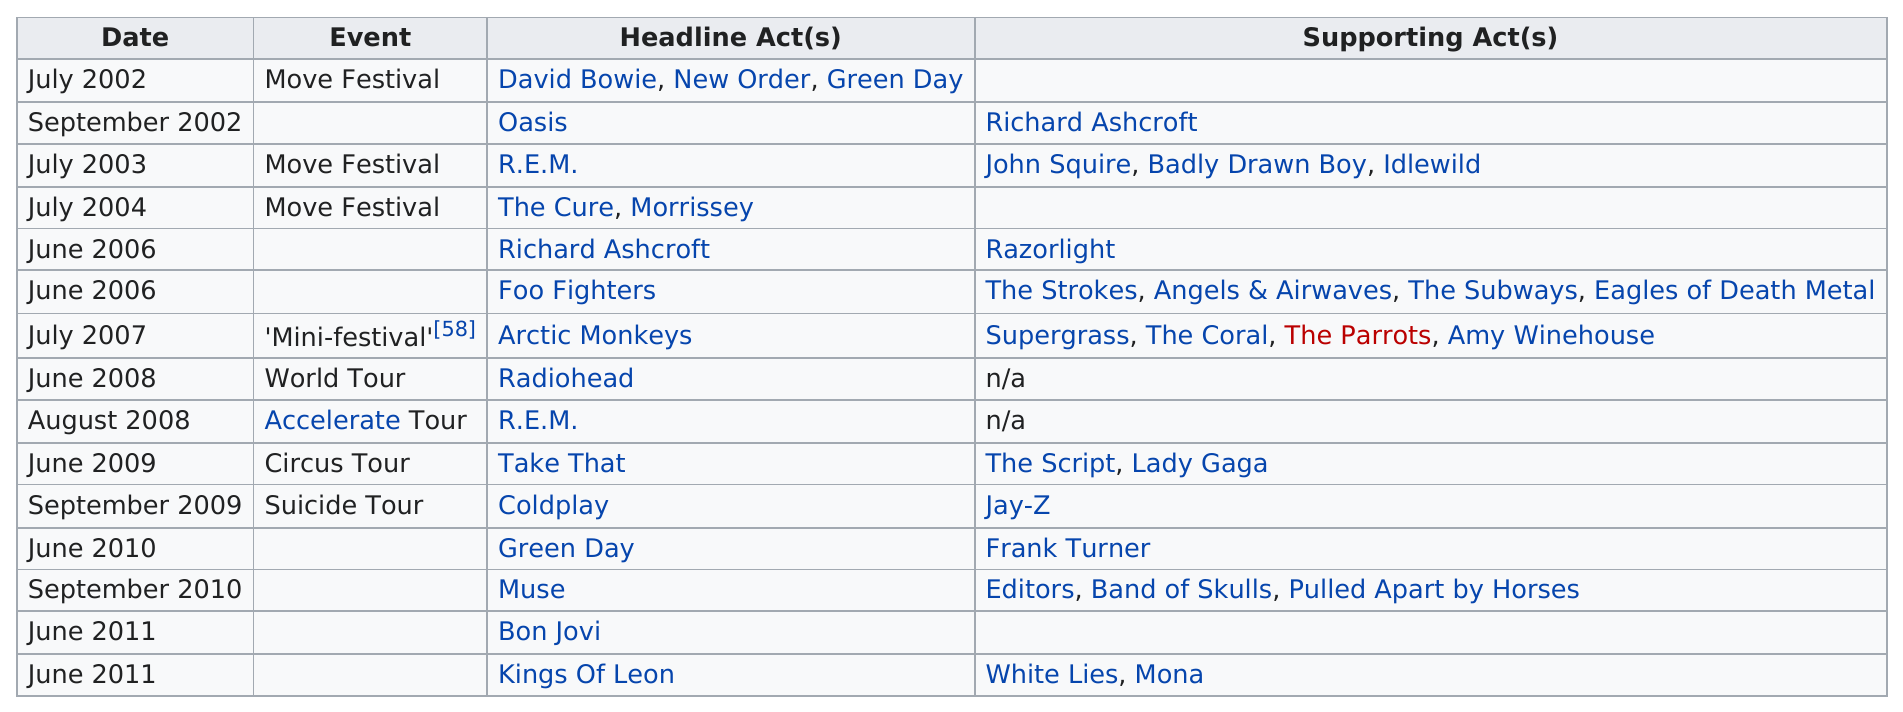Give some essential details in this illustration. The Move Festival is the most recurring event on the list. The most popular month for concerts at Old Trafford Cricket Ground is June. In the month of June, a total of 17 performances occurred. 